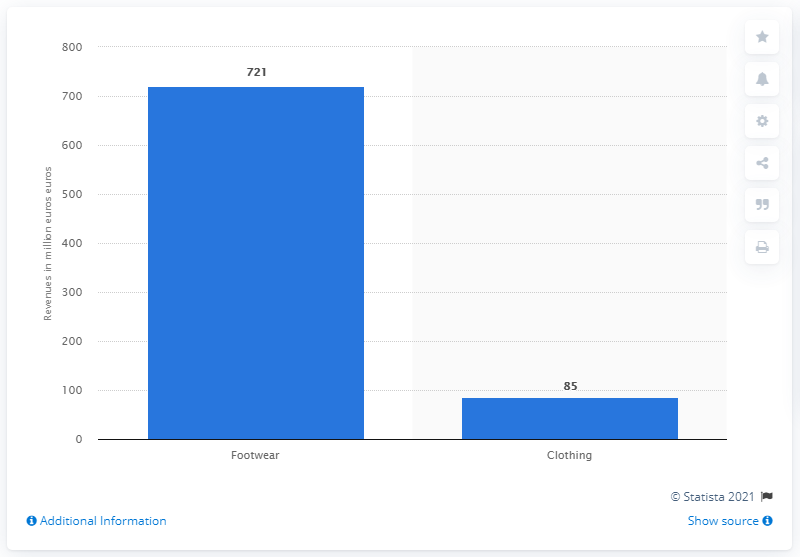List a handful of essential elements in this visual. Geox's footwear revenue in 2019 was approximately 721 million. 